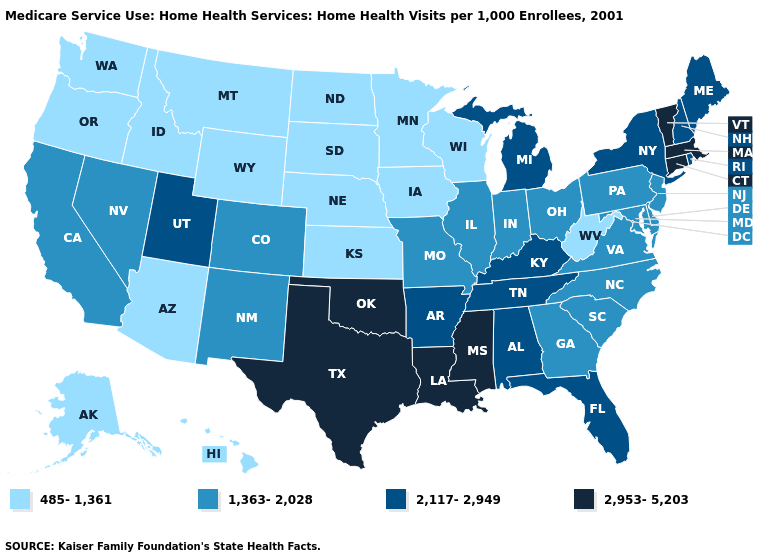Name the states that have a value in the range 2,953-5,203?
Be succinct. Connecticut, Louisiana, Massachusetts, Mississippi, Oklahoma, Texas, Vermont. What is the highest value in the USA?
Short answer required. 2,953-5,203. Name the states that have a value in the range 1,363-2,028?
Write a very short answer. California, Colorado, Delaware, Georgia, Illinois, Indiana, Maryland, Missouri, Nevada, New Jersey, New Mexico, North Carolina, Ohio, Pennsylvania, South Carolina, Virginia. What is the lowest value in the USA?
Quick response, please. 485-1,361. What is the value of Washington?
Short answer required. 485-1,361. What is the value of South Carolina?
Answer briefly. 1,363-2,028. Does Idaho have the lowest value in the USA?
Quick response, please. Yes. Does Ohio have the lowest value in the USA?
Keep it brief. No. What is the lowest value in the USA?
Keep it brief. 485-1,361. Which states have the lowest value in the USA?
Concise answer only. Alaska, Arizona, Hawaii, Idaho, Iowa, Kansas, Minnesota, Montana, Nebraska, North Dakota, Oregon, South Dakota, Washington, West Virginia, Wisconsin, Wyoming. Does Delaware have the same value as South Dakota?
Answer briefly. No. Which states hav the highest value in the MidWest?
Concise answer only. Michigan. What is the highest value in states that border Pennsylvania?
Concise answer only. 2,117-2,949. Name the states that have a value in the range 1,363-2,028?
Write a very short answer. California, Colorado, Delaware, Georgia, Illinois, Indiana, Maryland, Missouri, Nevada, New Jersey, New Mexico, North Carolina, Ohio, Pennsylvania, South Carolina, Virginia. What is the highest value in the USA?
Keep it brief. 2,953-5,203. 